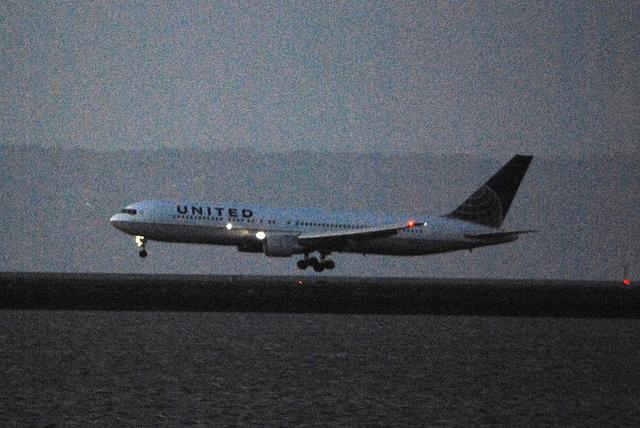Where is the plane taking off too?
Quick response, please. Europe. What airlines is this?
Quick response, please. United. What does the side of the plane say?
Answer briefly. United. What is the plane called?
Answer briefly. United. Is the plane getting ready to take off?
Keep it brief. Yes. Is this plane taking off?
Keep it brief. Yes. 